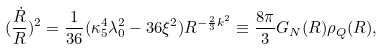Convert formula to latex. <formula><loc_0><loc_0><loc_500><loc_500>( \frac { \dot { R } } { R } ) ^ { 2 } = \frac { 1 } { 3 6 } ( \kappa _ { 5 } ^ { 4 } \lambda _ { 0 } ^ { 2 } - 3 6 \xi ^ { 2 } ) R ^ { - \frac { 2 } { 3 } k ^ { 2 } } \equiv \frac { 8 \pi } { 3 } G _ { N } ( R ) \rho _ { Q } ( R ) ,</formula> 